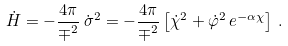Convert formula to latex. <formula><loc_0><loc_0><loc_500><loc_500>\dot { H } = - \frac { 4 \pi } { \mp ^ { 2 } } \, \dot { \sigma } ^ { 2 } = - \frac { 4 \pi } { \mp ^ { 2 } } \left [ \dot { \chi } ^ { 2 } + \dot { \varphi } ^ { 2 } \, e ^ { - \alpha \chi } \right ] \, .</formula> 